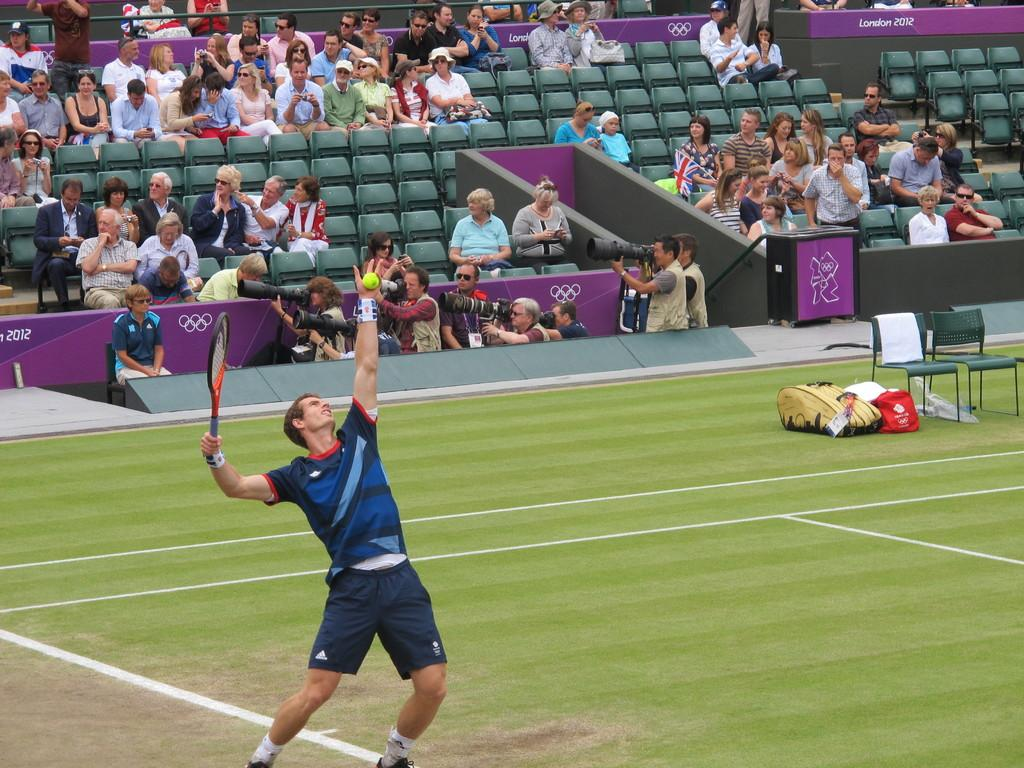<image>
Provide a brief description of the given image. A man playing tennis in front of a crowd during a tennis match as he is dressed in Adidas brand shorts. 